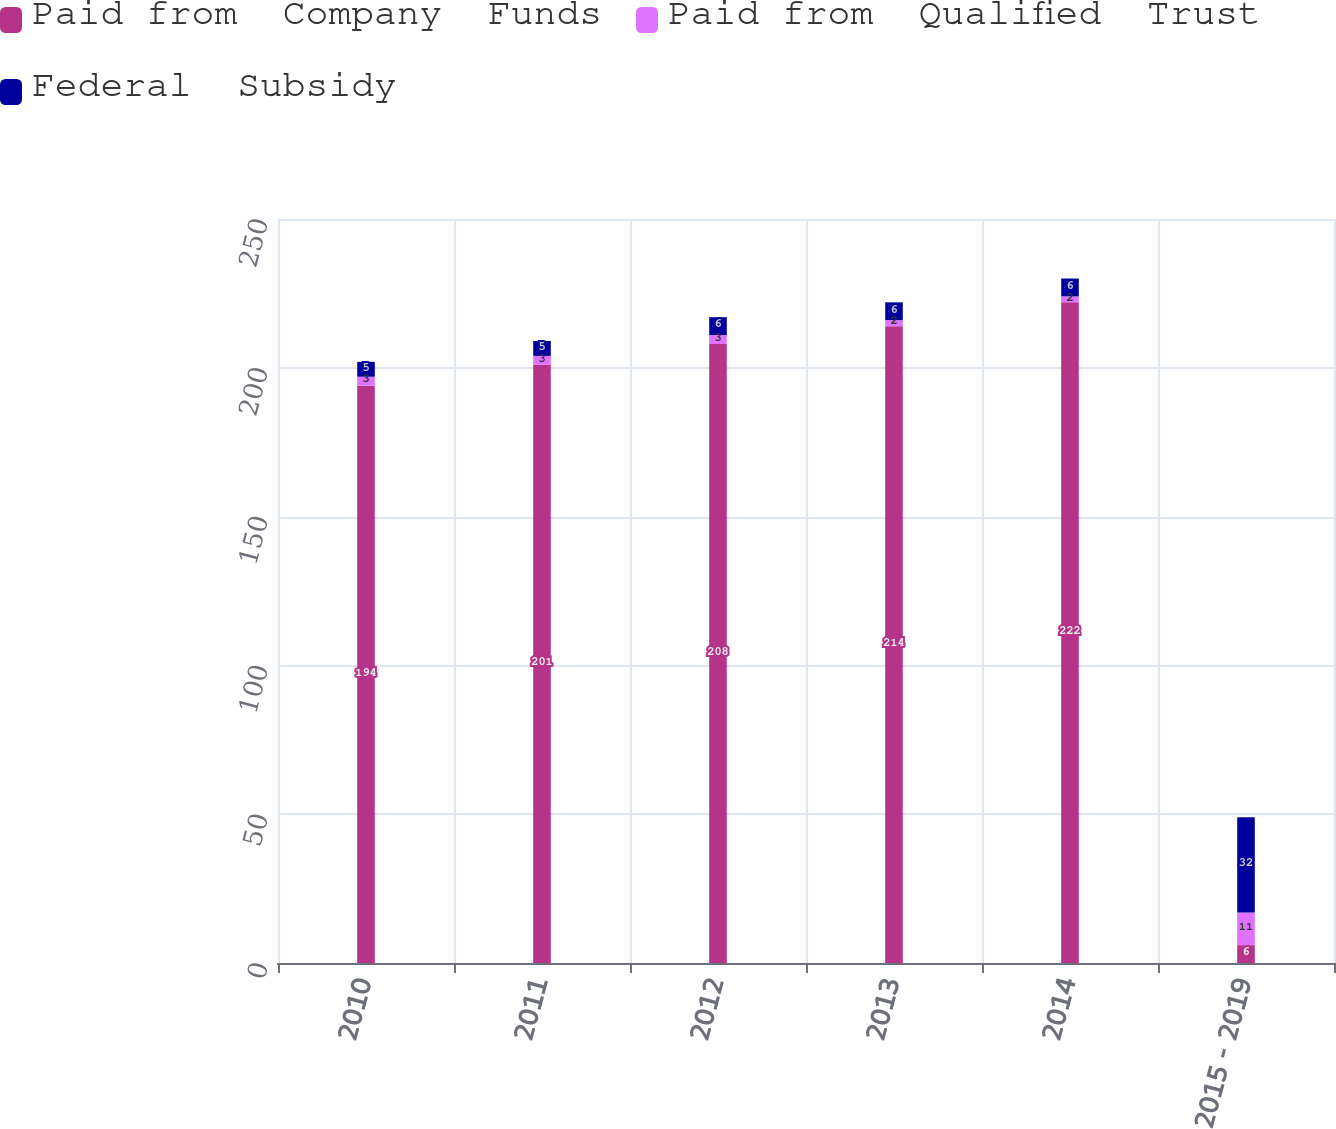Convert chart to OTSL. <chart><loc_0><loc_0><loc_500><loc_500><stacked_bar_chart><ecel><fcel>2010<fcel>2011<fcel>2012<fcel>2013<fcel>2014<fcel>2015 - 2019<nl><fcel>Paid from  Company  Funds<fcel>194<fcel>201<fcel>208<fcel>214<fcel>222<fcel>6<nl><fcel>Paid from  Qualified  Trust<fcel>3<fcel>3<fcel>3<fcel>2<fcel>2<fcel>11<nl><fcel>Federal  Subsidy<fcel>5<fcel>5<fcel>6<fcel>6<fcel>6<fcel>32<nl></chart> 